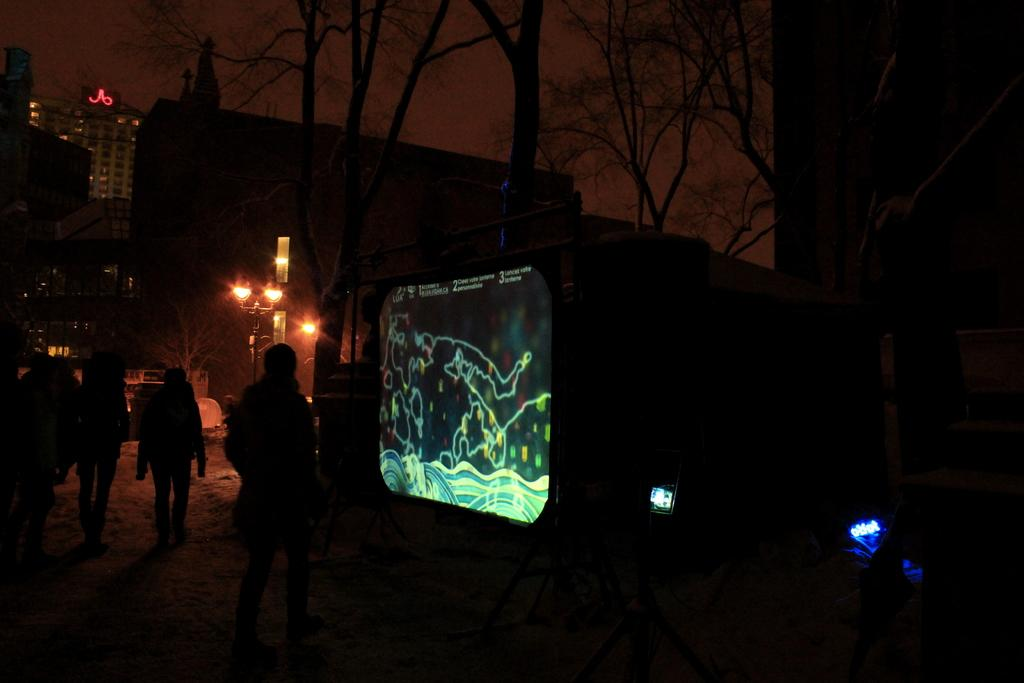How many people are in the image? There is a group of persons in the image. What are the persons in the image doing? The group of persons is walking in a walking area. What is the large screen-like object in the image? There is a projector screen in the image. What can be seen in the background of the image? There are buildings and street light poles in the background of the image. What type of skin condition is visible on the persons in the image? There is no indication of any skin condition visible on the persons in the image. How does the road in the image adjust to the walking area? There is no road present in the image; it is a walking area. 